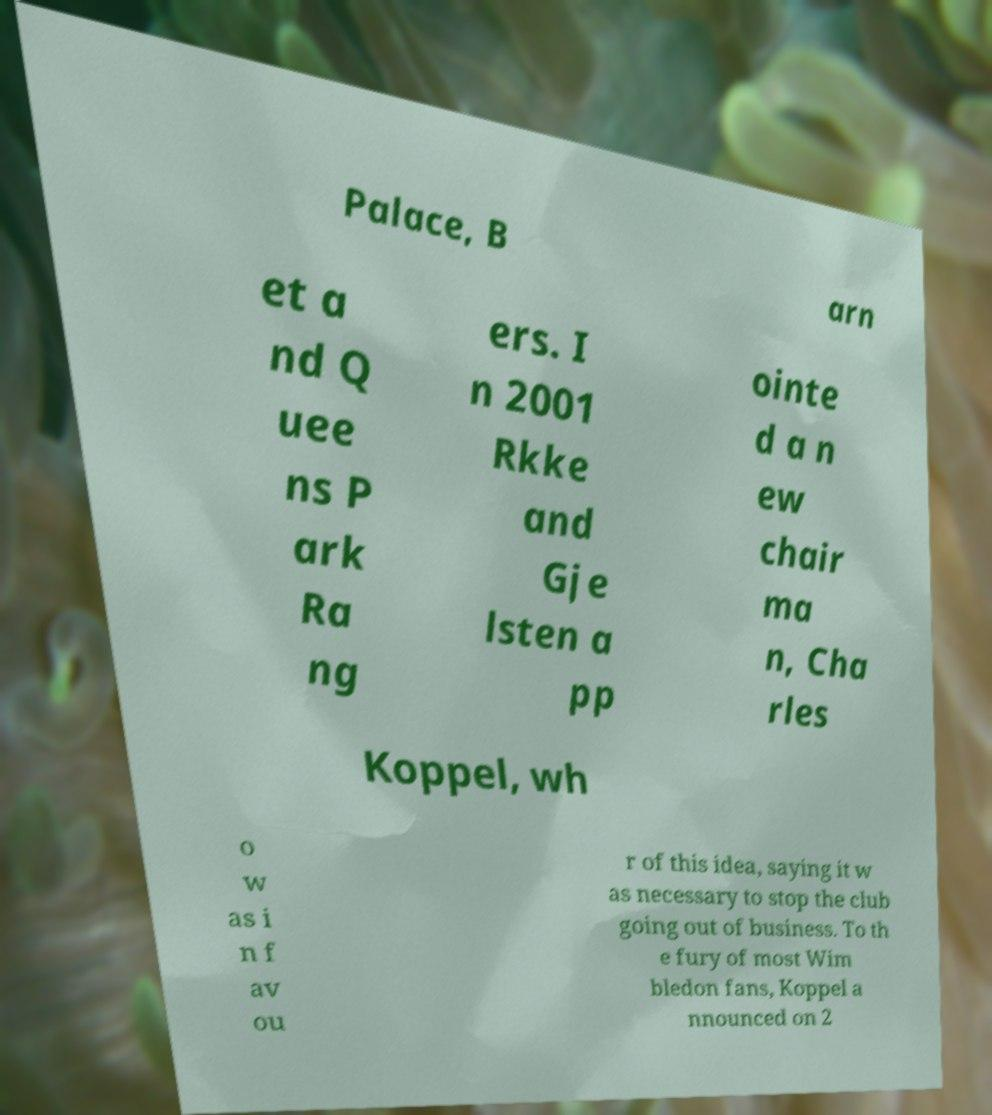Can you accurately transcribe the text from the provided image for me? Palace, B arn et a nd Q uee ns P ark Ra ng ers. I n 2001 Rkke and Gje lsten a pp ointe d a n ew chair ma n, Cha rles Koppel, wh o w as i n f av ou r of this idea, saying it w as necessary to stop the club going out of business. To th e fury of most Wim bledon fans, Koppel a nnounced on 2 